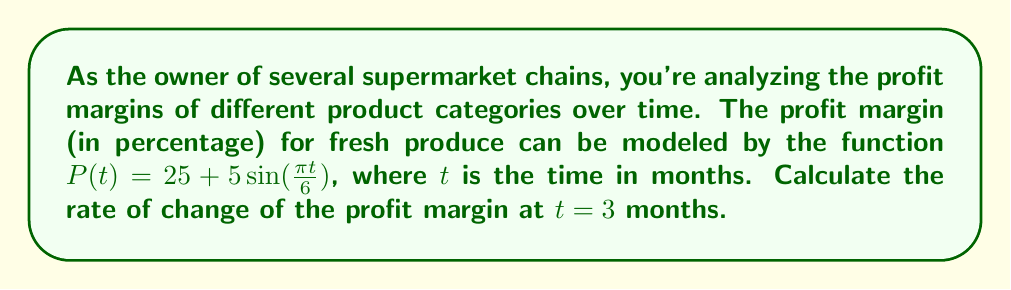Can you solve this math problem? To find the rate of change of the profit margin at $t = 3$ months, we need to calculate the derivative of $P(t)$ and evaluate it at $t = 3$.

1. Start with the given function:
   $P(t) = 25 + 5\sin(\frac{\pi t}{6})$

2. Calculate the derivative using the chain rule:
   $$\frac{dP}{dt} = 5 \cdot \cos(\frac{\pi t}{6}) \cdot \frac{\pi}{6}$$
   $$\frac{dP}{dt} = \frac{5\pi}{6} \cos(\frac{\pi t}{6})$$

3. Evaluate the derivative at $t = 3$:
   $$\frac{dP}{dt}\bigg|_{t=3} = \frac{5\pi}{6} \cos(\frac{\pi \cdot 3}{6})$$
   $$= \frac{5\pi}{6} \cos(\frac{\pi}{2})$$
   $$= \frac{5\pi}{6} \cdot 0$$
   $$= 0$$

The rate of change of the profit margin at $t = 3$ months is 0 percent per month.
Answer: 0 percent per month 